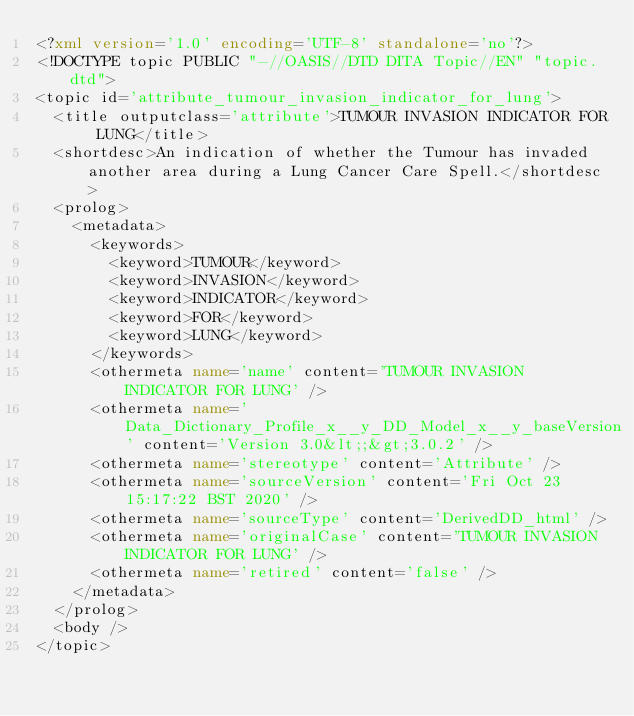Convert code to text. <code><loc_0><loc_0><loc_500><loc_500><_XML_><?xml version='1.0' encoding='UTF-8' standalone='no'?>
<!DOCTYPE topic PUBLIC "-//OASIS//DTD DITA Topic//EN" "topic.dtd">
<topic id='attribute_tumour_invasion_indicator_for_lung'>
  <title outputclass='attribute'>TUMOUR INVASION INDICATOR FOR LUNG</title>
  <shortdesc>An indication of whether the Tumour has invaded another area during a Lung Cancer Care Spell.</shortdesc>
  <prolog>
    <metadata>
      <keywords>
        <keyword>TUMOUR</keyword>
        <keyword>INVASION</keyword>
        <keyword>INDICATOR</keyword>
        <keyword>FOR</keyword>
        <keyword>LUNG</keyword>
      </keywords>
      <othermeta name='name' content='TUMOUR INVASION INDICATOR FOR LUNG' />
      <othermeta name='Data_Dictionary_Profile_x__y_DD_Model_x__y_baseVersion' content='Version 3.0&lt;;&gt;3.0.2' />
      <othermeta name='stereotype' content='Attribute' />
      <othermeta name='sourceVersion' content='Fri Oct 23 15:17:22 BST 2020' />
      <othermeta name='sourceType' content='DerivedDD_html' />
      <othermeta name='originalCase' content='TUMOUR INVASION INDICATOR FOR LUNG' />
      <othermeta name='retired' content='false' />
    </metadata>
  </prolog>
  <body />
</topic></code> 